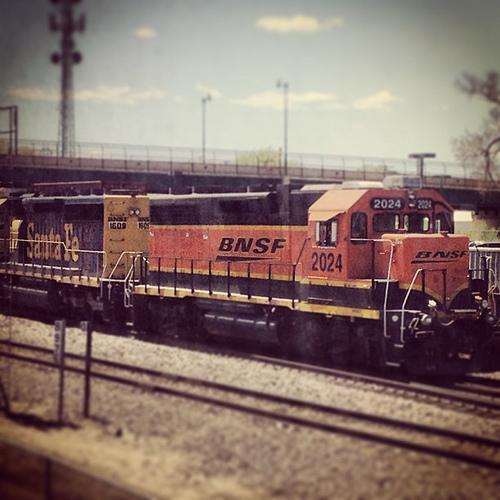How many trains are there?
Give a very brief answer. 1. 